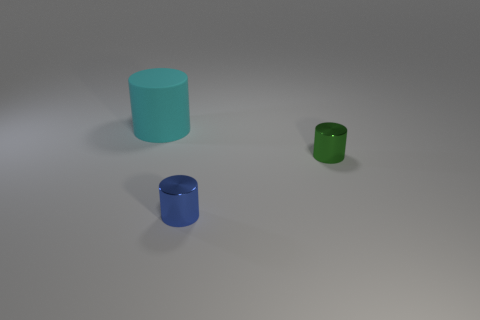Subtract all large rubber cylinders. How many cylinders are left? 2 Add 1 tiny cylinders. How many objects exist? 4 Subtract 1 cylinders. How many cylinders are left? 2 Subtract all purple spheres. How many yellow cylinders are left? 0 Subtract all tiny things. Subtract all tiny cyan shiny things. How many objects are left? 1 Add 3 small blue shiny things. How many small blue shiny things are left? 4 Add 1 cyan shiny balls. How many cyan shiny balls exist? 1 Subtract all green cylinders. How many cylinders are left? 2 Subtract 0 red cubes. How many objects are left? 3 Subtract all yellow cylinders. Subtract all gray spheres. How many cylinders are left? 3 